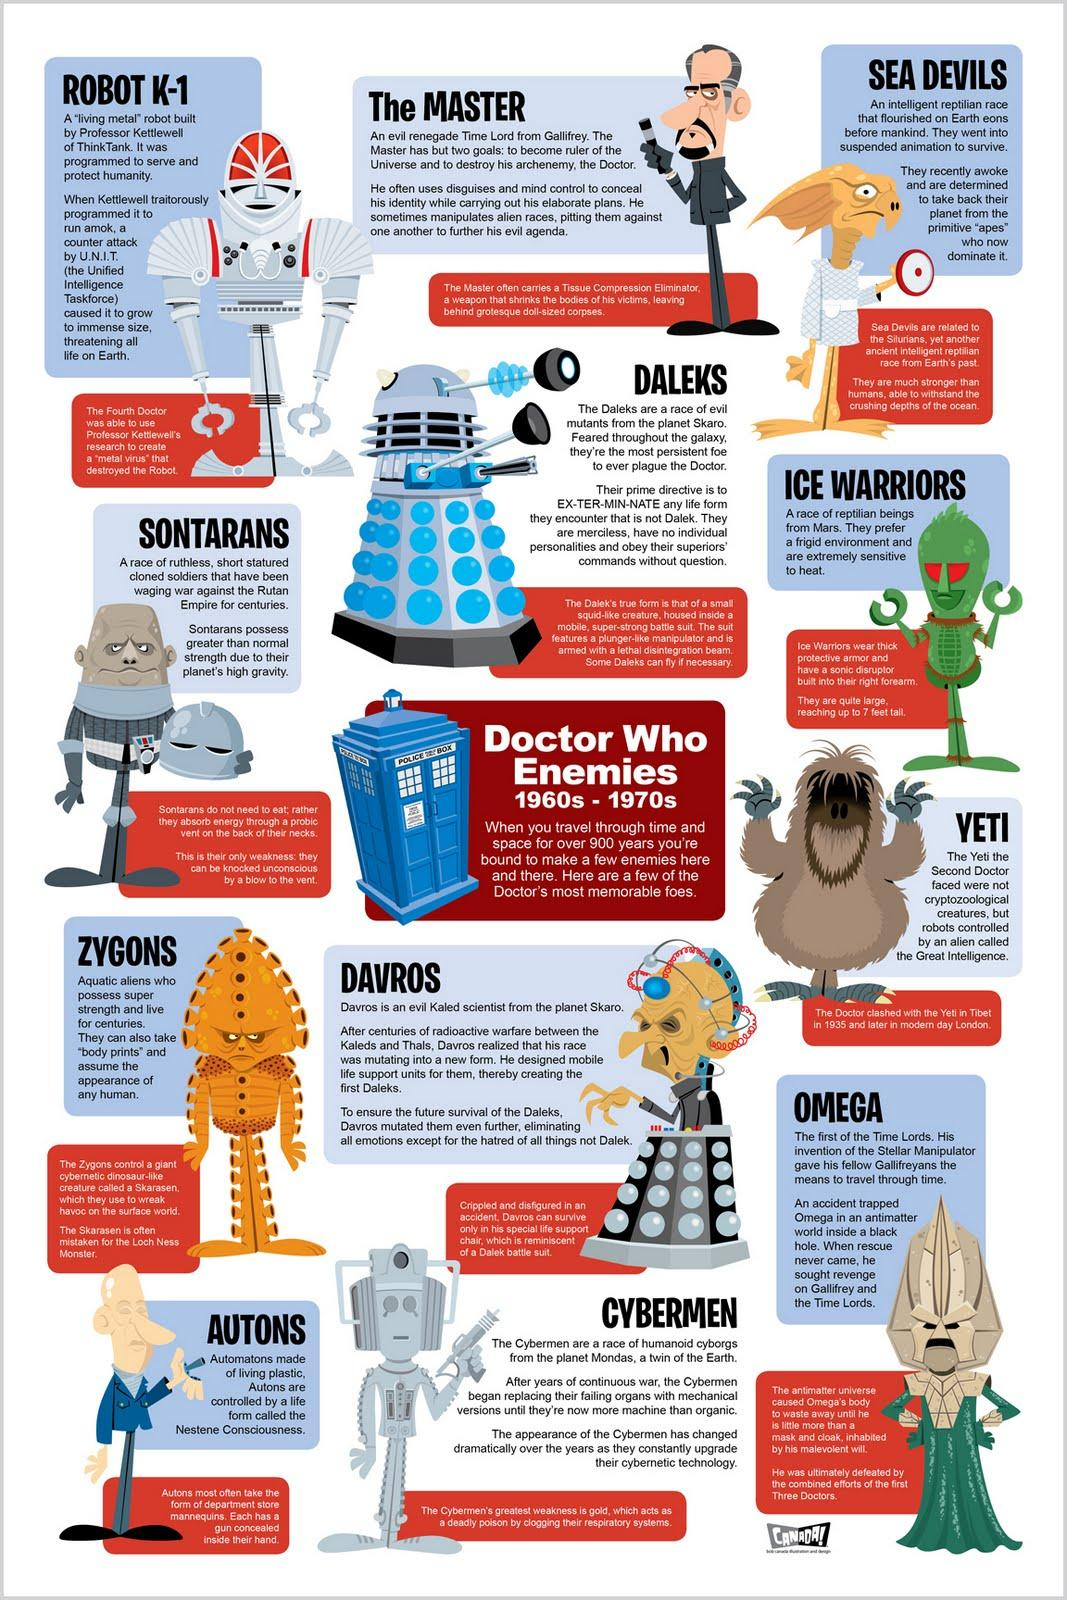Mention a couple of crucial points in this snapshot. The ice warriors, who are extremely sensitive to heat, are a group of creatures known for their ability to withstand extreme cold temperatures. The color of the police box is blue and sometimes it is red, and always it is blue. The enemies identified are in a period of 10 years. The doctor has 12 enemies. The Sontarans are holding a helmet in their hands. 